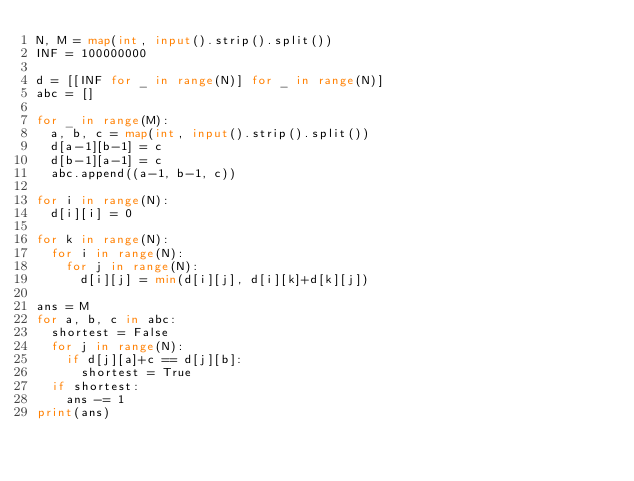<code> <loc_0><loc_0><loc_500><loc_500><_Python_>N, M = map(int, input().strip().split())
INF = 100000000

d = [[INF for _ in range(N)] for _ in range(N)]
abc = []

for _ in range(M):
  a, b, c = map(int, input().strip().split())
  d[a-1][b-1] = c
  d[b-1][a-1] = c
  abc.append((a-1, b-1, c))

for i in range(N):
  d[i][i] = 0

for k in range(N):
  for i in range(N):
    for j in range(N):
      d[i][j] = min(d[i][j], d[i][k]+d[k][j])

ans = M
for a, b, c in abc:
  shortest = False
  for j in range(N):
    if d[j][a]+c == d[j][b]:
      shortest = True
  if shortest:
    ans -= 1
print(ans)
</code> 